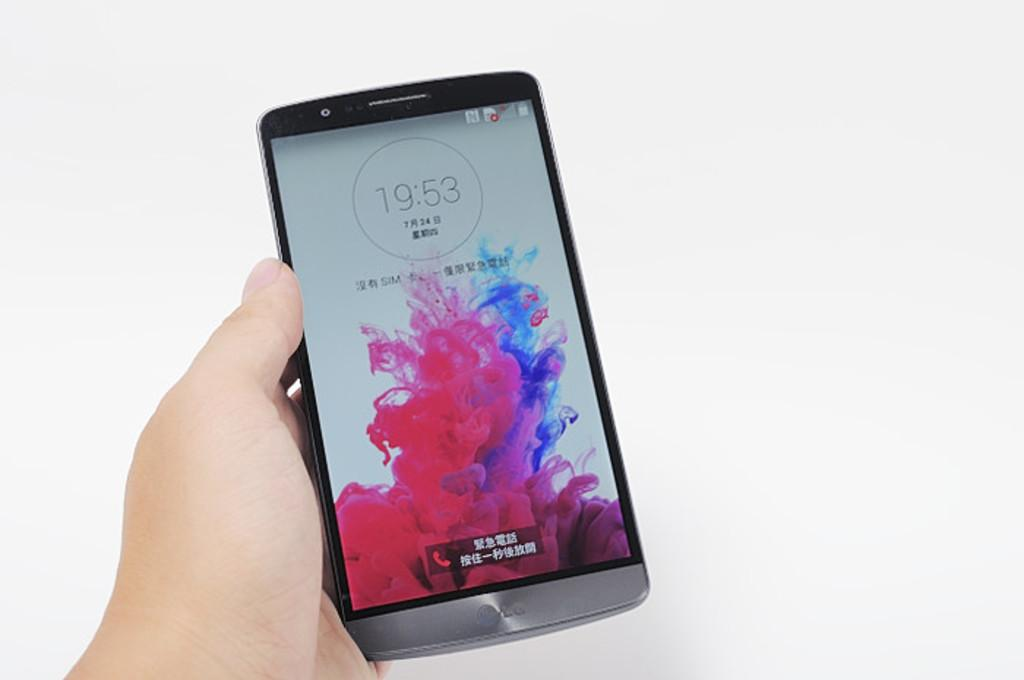<image>
Write a terse but informative summary of the picture. A smart phone being held in a hand that says 19:53. 